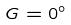Convert formula to latex. <formula><loc_0><loc_0><loc_500><loc_500>G = 0 ^ { \circ }</formula> 